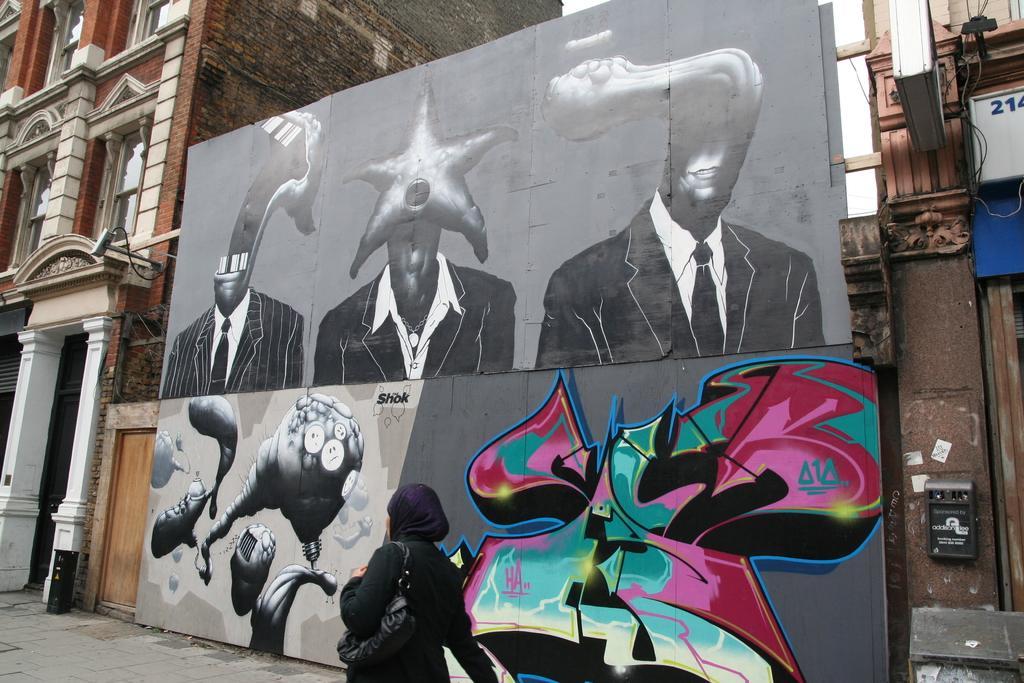Please provide a concise description of this image. This image consists of a wall. On which we can see a painting. On the left and right, there are buildings along with windows. At the bottom, there is a road. And we can see a door made up of wood. 